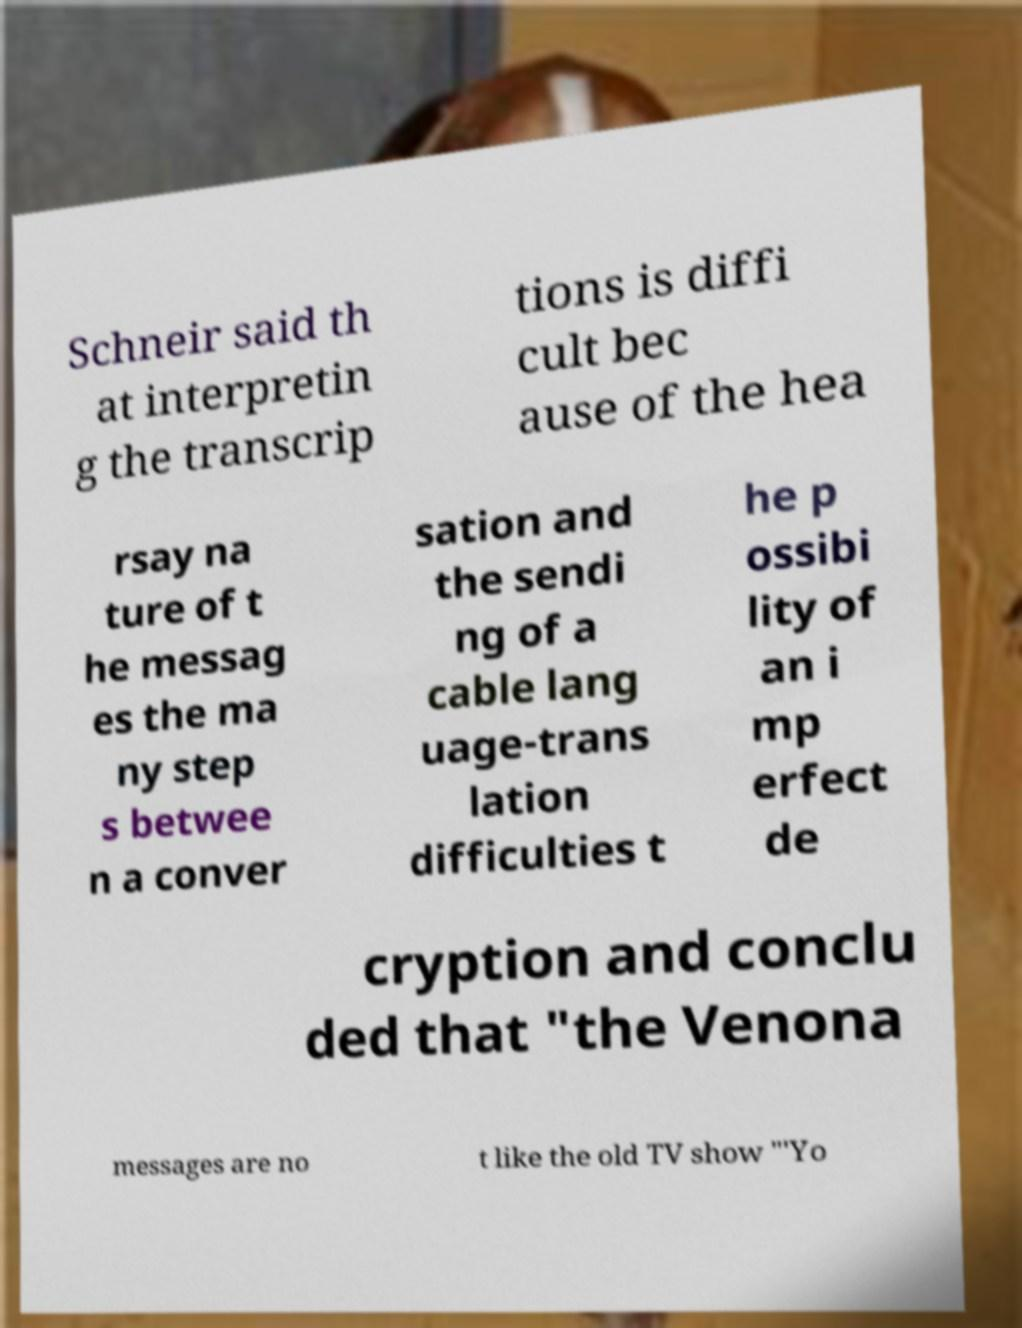I need the written content from this picture converted into text. Can you do that? Schneir said th at interpretin g the transcrip tions is diffi cult bec ause of the hea rsay na ture of t he messag es the ma ny step s betwee n a conver sation and the sendi ng of a cable lang uage-trans lation difficulties t he p ossibi lity of an i mp erfect de cryption and conclu ded that "the Venona messages are no t like the old TV show "'Yo 